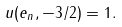<formula> <loc_0><loc_0><loc_500><loc_500>u ( e _ { n } , - 3 / 2 ) = 1 .</formula> 